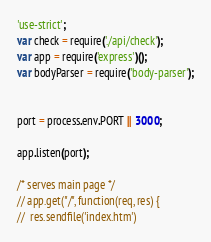<code> <loc_0><loc_0><loc_500><loc_500><_JavaScript_>'use-strict';
var check = require('./api/check');
var app = require('express')();
var bodyParser = require('body-parser');


port = process.env.PORT || 3000;

app.listen(port);

/* serves main page */
// app.get("/", function(req, res) {
// 	res.sendfile('index.htm')</code> 